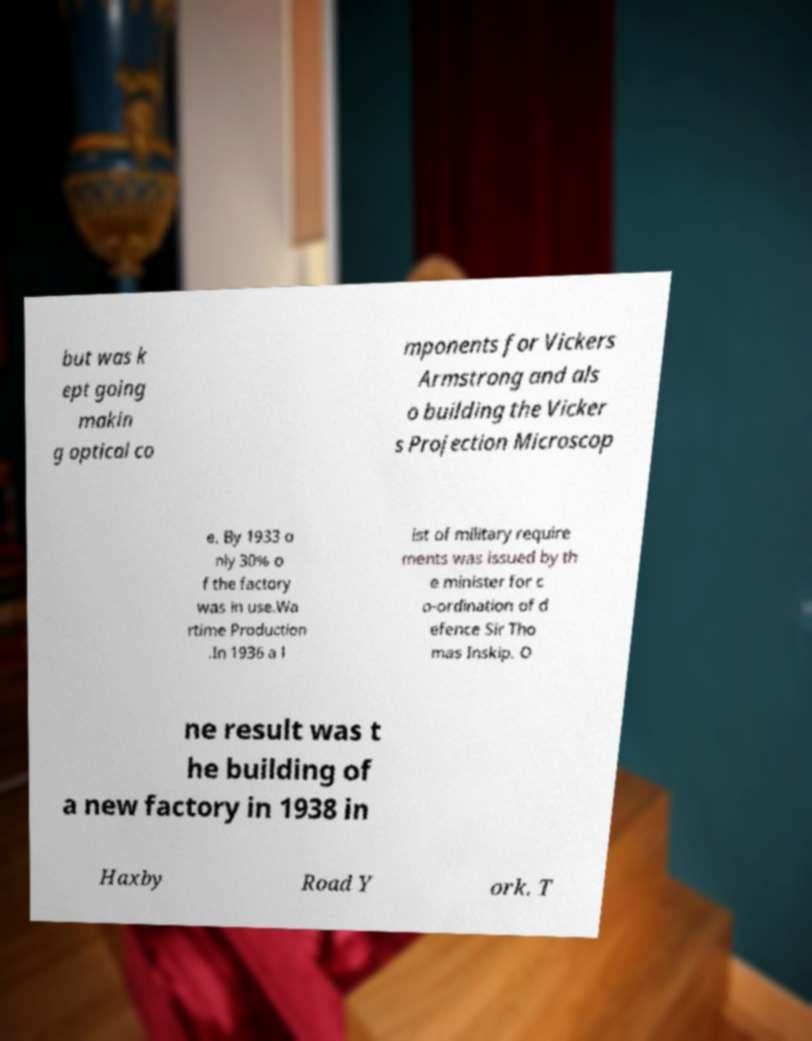What messages or text are displayed in this image? I need them in a readable, typed format. but was k ept going makin g optical co mponents for Vickers Armstrong and als o building the Vicker s Projection Microscop e. By 1933 o nly 30% o f the factory was in use.Wa rtime Production .In 1936 a l ist of military require ments was issued by th e minister for c o-ordination of d efence Sir Tho mas Inskip. O ne result was t he building of a new factory in 1938 in Haxby Road Y ork. T 